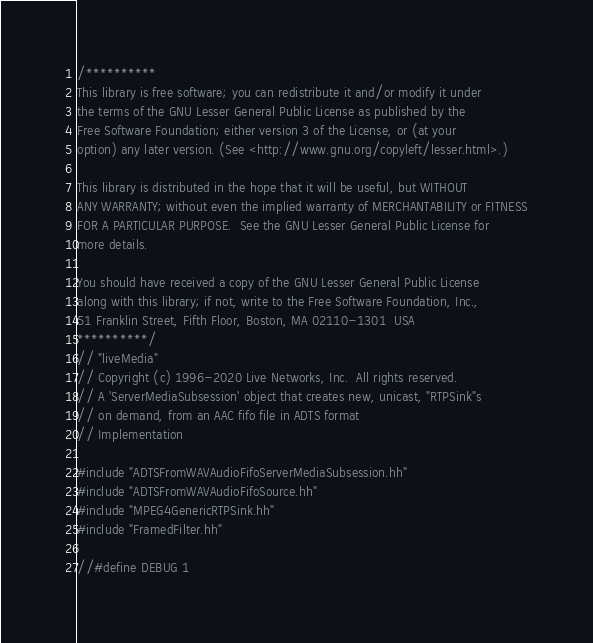<code> <loc_0><loc_0><loc_500><loc_500><_C++_>/**********
This library is free software; you can redistribute it and/or modify it under
the terms of the GNU Lesser General Public License as published by the
Free Software Foundation; either version 3 of the License, or (at your
option) any later version. (See <http://www.gnu.org/copyleft/lesser.html>.)

This library is distributed in the hope that it will be useful, but WITHOUT
ANY WARRANTY; without even the implied warranty of MERCHANTABILITY or FITNESS
FOR A PARTICULAR PURPOSE.  See the GNU Lesser General Public License for
more details.

You should have received a copy of the GNU Lesser General Public License
along with this library; if not, write to the Free Software Foundation, Inc.,
51 Franklin Street, Fifth Floor, Boston, MA 02110-1301  USA
**********/
// "liveMedia"
// Copyright (c) 1996-2020 Live Networks, Inc.  All rights reserved.
// A 'ServerMediaSubsession' object that creates new, unicast, "RTPSink"s
// on demand, from an AAC fifo file in ADTS format
// Implementation

#include "ADTSFromWAVAudioFifoServerMediaSubsession.hh"
#include "ADTSFromWAVAudioFifoSource.hh"
#include "MPEG4GenericRTPSink.hh"
#include "FramedFilter.hh"

//#define DEBUG 1
</code> 